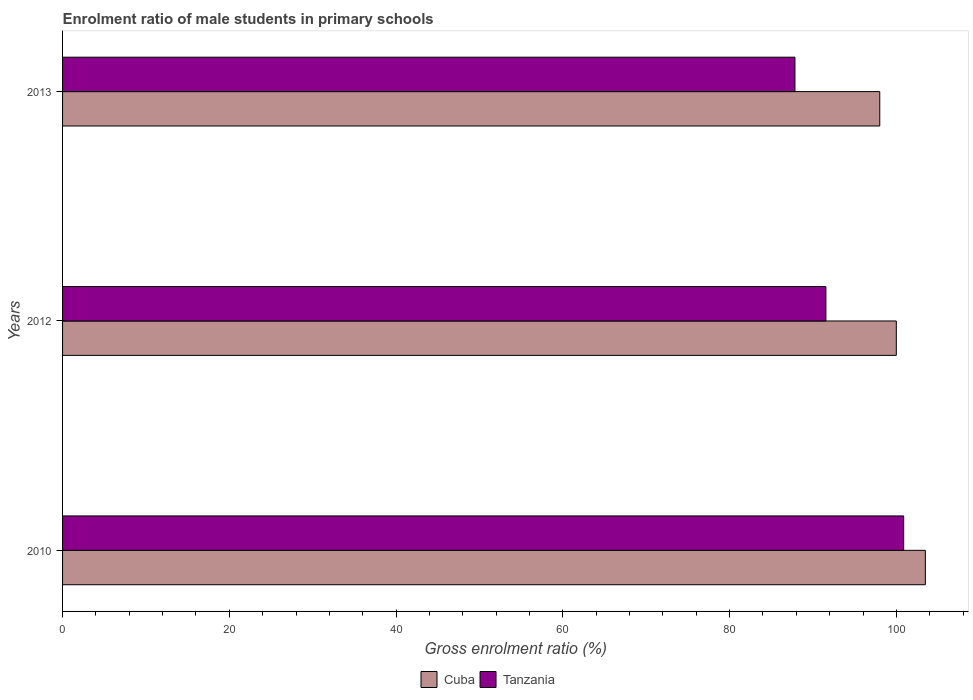Are the number of bars per tick equal to the number of legend labels?
Your answer should be compact. Yes. Are the number of bars on each tick of the Y-axis equal?
Give a very brief answer. Yes. How many bars are there on the 3rd tick from the top?
Give a very brief answer. 2. How many bars are there on the 2nd tick from the bottom?
Offer a terse response. 2. What is the label of the 2nd group of bars from the top?
Keep it short and to the point. 2012. What is the enrolment ratio of male students in primary schools in Cuba in 2010?
Your response must be concise. 103.48. Across all years, what is the maximum enrolment ratio of male students in primary schools in Tanzania?
Make the answer very short. 100.87. Across all years, what is the minimum enrolment ratio of male students in primary schools in Cuba?
Provide a short and direct response. 98.01. In which year was the enrolment ratio of male students in primary schools in Cuba maximum?
Keep it short and to the point. 2010. In which year was the enrolment ratio of male students in primary schools in Cuba minimum?
Provide a short and direct response. 2013. What is the total enrolment ratio of male students in primary schools in Tanzania in the graph?
Make the answer very short. 280.26. What is the difference between the enrolment ratio of male students in primary schools in Tanzania in 2012 and that in 2013?
Give a very brief answer. 3.71. What is the difference between the enrolment ratio of male students in primary schools in Tanzania in 2010 and the enrolment ratio of male students in primary schools in Cuba in 2012?
Make the answer very short. 0.88. What is the average enrolment ratio of male students in primary schools in Tanzania per year?
Keep it short and to the point. 93.42. In the year 2010, what is the difference between the enrolment ratio of male students in primary schools in Tanzania and enrolment ratio of male students in primary schools in Cuba?
Offer a very short reply. -2.6. What is the ratio of the enrolment ratio of male students in primary schools in Tanzania in 2010 to that in 2013?
Ensure brevity in your answer.  1.15. Is the difference between the enrolment ratio of male students in primary schools in Tanzania in 2012 and 2013 greater than the difference between the enrolment ratio of male students in primary schools in Cuba in 2012 and 2013?
Provide a short and direct response. Yes. What is the difference between the highest and the second highest enrolment ratio of male students in primary schools in Cuba?
Provide a succinct answer. 3.48. What is the difference between the highest and the lowest enrolment ratio of male students in primary schools in Cuba?
Provide a succinct answer. 5.47. In how many years, is the enrolment ratio of male students in primary schools in Cuba greater than the average enrolment ratio of male students in primary schools in Cuba taken over all years?
Your answer should be compact. 1. Is the sum of the enrolment ratio of male students in primary schools in Tanzania in 2010 and 2013 greater than the maximum enrolment ratio of male students in primary schools in Cuba across all years?
Ensure brevity in your answer.  Yes. What does the 1st bar from the top in 2013 represents?
Ensure brevity in your answer.  Tanzania. What does the 1st bar from the bottom in 2010 represents?
Make the answer very short. Cuba. How many bars are there?
Ensure brevity in your answer.  6. What is the difference between two consecutive major ticks on the X-axis?
Your answer should be very brief. 20. Does the graph contain any zero values?
Provide a succinct answer. No. Does the graph contain grids?
Your answer should be compact. No. Where does the legend appear in the graph?
Your answer should be very brief. Bottom center. How many legend labels are there?
Offer a very short reply. 2. What is the title of the graph?
Your response must be concise. Enrolment ratio of male students in primary schools. Does "Samoa" appear as one of the legend labels in the graph?
Offer a very short reply. No. What is the label or title of the X-axis?
Ensure brevity in your answer.  Gross enrolment ratio (%). What is the Gross enrolment ratio (%) in Cuba in 2010?
Provide a short and direct response. 103.48. What is the Gross enrolment ratio (%) of Tanzania in 2010?
Keep it short and to the point. 100.87. What is the Gross enrolment ratio (%) in Cuba in 2012?
Provide a succinct answer. 99.99. What is the Gross enrolment ratio (%) of Tanzania in 2012?
Provide a succinct answer. 91.55. What is the Gross enrolment ratio (%) in Cuba in 2013?
Ensure brevity in your answer.  98.01. What is the Gross enrolment ratio (%) of Tanzania in 2013?
Your response must be concise. 87.84. Across all years, what is the maximum Gross enrolment ratio (%) in Cuba?
Offer a terse response. 103.48. Across all years, what is the maximum Gross enrolment ratio (%) of Tanzania?
Offer a terse response. 100.87. Across all years, what is the minimum Gross enrolment ratio (%) of Cuba?
Ensure brevity in your answer.  98.01. Across all years, what is the minimum Gross enrolment ratio (%) of Tanzania?
Your response must be concise. 87.84. What is the total Gross enrolment ratio (%) in Cuba in the graph?
Offer a very short reply. 301.48. What is the total Gross enrolment ratio (%) in Tanzania in the graph?
Offer a very short reply. 280.26. What is the difference between the Gross enrolment ratio (%) in Cuba in 2010 and that in 2012?
Offer a very short reply. 3.48. What is the difference between the Gross enrolment ratio (%) in Tanzania in 2010 and that in 2012?
Ensure brevity in your answer.  9.33. What is the difference between the Gross enrolment ratio (%) in Cuba in 2010 and that in 2013?
Provide a succinct answer. 5.47. What is the difference between the Gross enrolment ratio (%) in Tanzania in 2010 and that in 2013?
Provide a short and direct response. 13.04. What is the difference between the Gross enrolment ratio (%) in Cuba in 2012 and that in 2013?
Keep it short and to the point. 1.99. What is the difference between the Gross enrolment ratio (%) in Tanzania in 2012 and that in 2013?
Offer a very short reply. 3.71. What is the difference between the Gross enrolment ratio (%) in Cuba in 2010 and the Gross enrolment ratio (%) in Tanzania in 2012?
Your response must be concise. 11.93. What is the difference between the Gross enrolment ratio (%) of Cuba in 2010 and the Gross enrolment ratio (%) of Tanzania in 2013?
Your answer should be very brief. 15.64. What is the difference between the Gross enrolment ratio (%) of Cuba in 2012 and the Gross enrolment ratio (%) of Tanzania in 2013?
Offer a terse response. 12.16. What is the average Gross enrolment ratio (%) in Cuba per year?
Keep it short and to the point. 100.49. What is the average Gross enrolment ratio (%) of Tanzania per year?
Provide a short and direct response. 93.42. In the year 2010, what is the difference between the Gross enrolment ratio (%) of Cuba and Gross enrolment ratio (%) of Tanzania?
Make the answer very short. 2.6. In the year 2012, what is the difference between the Gross enrolment ratio (%) in Cuba and Gross enrolment ratio (%) in Tanzania?
Your response must be concise. 8.45. In the year 2013, what is the difference between the Gross enrolment ratio (%) of Cuba and Gross enrolment ratio (%) of Tanzania?
Provide a succinct answer. 10.17. What is the ratio of the Gross enrolment ratio (%) in Cuba in 2010 to that in 2012?
Provide a succinct answer. 1.03. What is the ratio of the Gross enrolment ratio (%) in Tanzania in 2010 to that in 2012?
Make the answer very short. 1.1. What is the ratio of the Gross enrolment ratio (%) of Cuba in 2010 to that in 2013?
Your answer should be compact. 1.06. What is the ratio of the Gross enrolment ratio (%) in Tanzania in 2010 to that in 2013?
Offer a very short reply. 1.15. What is the ratio of the Gross enrolment ratio (%) in Cuba in 2012 to that in 2013?
Make the answer very short. 1.02. What is the ratio of the Gross enrolment ratio (%) in Tanzania in 2012 to that in 2013?
Your answer should be compact. 1.04. What is the difference between the highest and the second highest Gross enrolment ratio (%) of Cuba?
Provide a succinct answer. 3.48. What is the difference between the highest and the second highest Gross enrolment ratio (%) of Tanzania?
Your response must be concise. 9.33. What is the difference between the highest and the lowest Gross enrolment ratio (%) in Cuba?
Provide a short and direct response. 5.47. What is the difference between the highest and the lowest Gross enrolment ratio (%) of Tanzania?
Your answer should be compact. 13.04. 